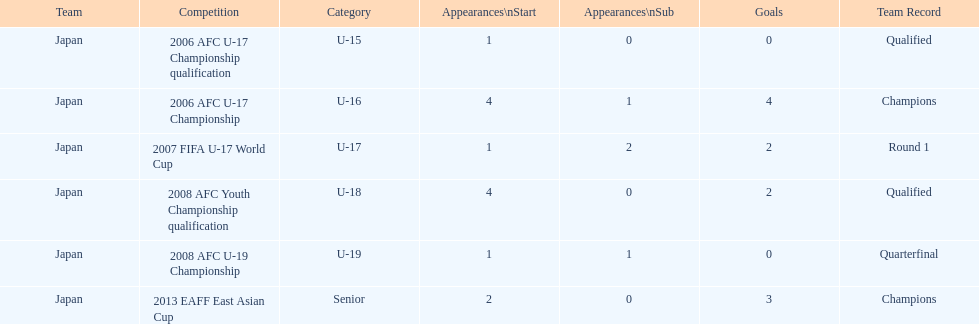Did japan have more starting appearances in the 2013 eaff east asian cup or 2007 fifa u-17 world cup? 2013 EAFF East Asian Cup. 